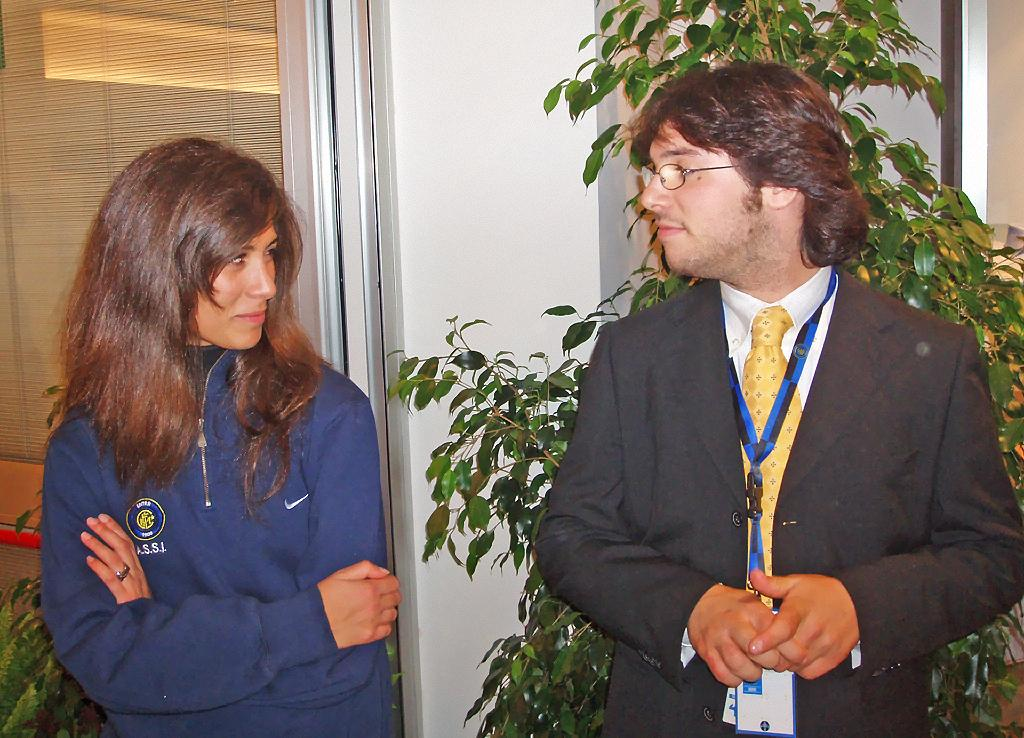How many people are present in the image? There is a man and a woman standing in the image. What can be seen in the background of the image? There is a plant and a wall in the background of the image. Is there any architectural feature associated with the wall? Yes, there is a door associated with the wall in the background of the image. What type of error can be seen in the design of the base in the image? There is no base or design error present in the image. 